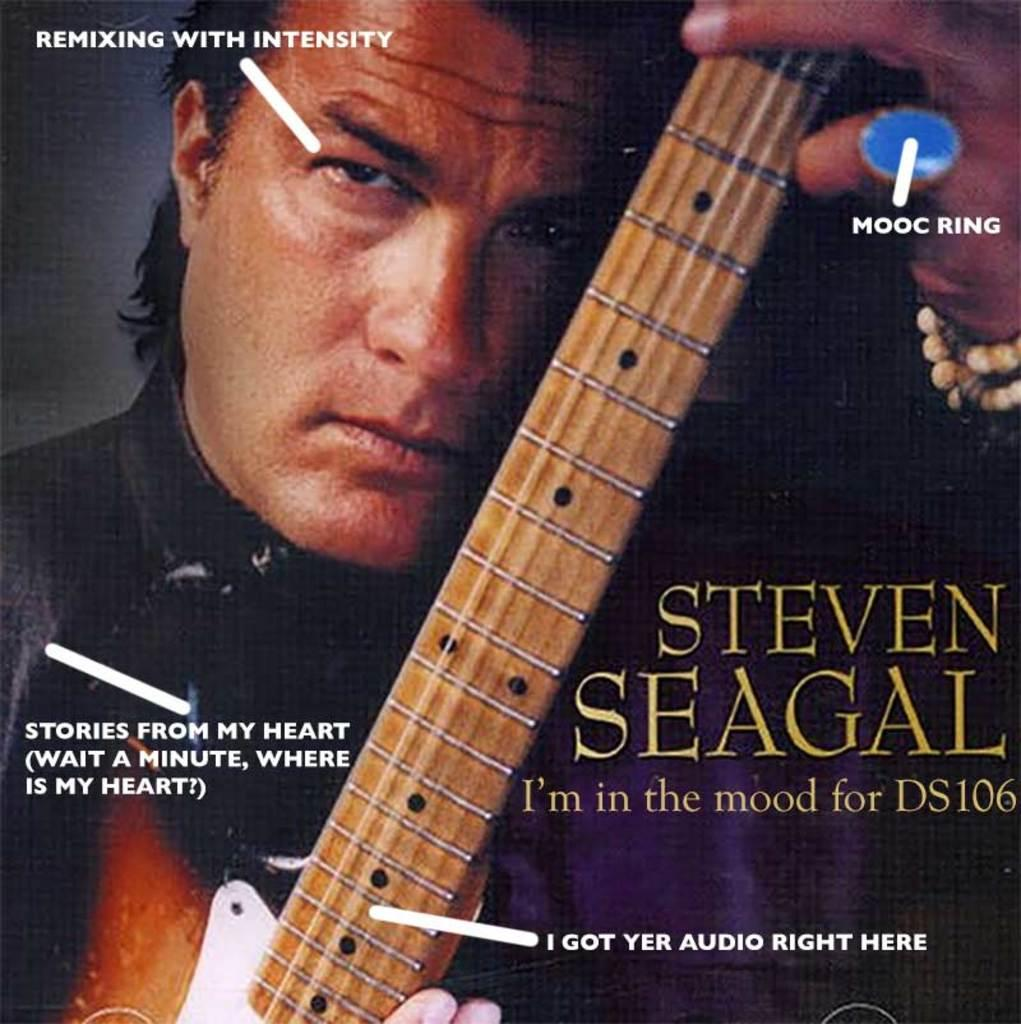What is depicted on the poster in the image? The poster features a man holding a music instrument. What else can be seen on the poster besides the man and the music instrument? There are words and numbers on the poster. What type of spring is visible in the image? There is no spring present in the image; it features a poster with a man holding a music instrument and text. 